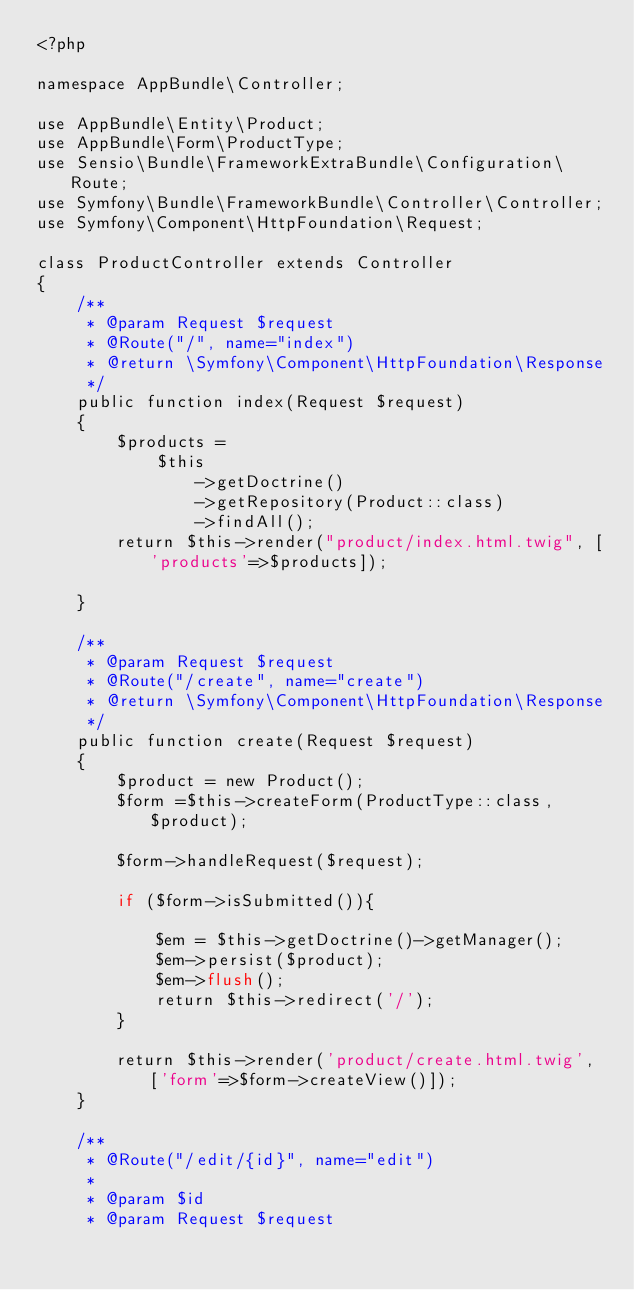<code> <loc_0><loc_0><loc_500><loc_500><_PHP_><?php

namespace AppBundle\Controller;

use AppBundle\Entity\Product;
use AppBundle\Form\ProductType;
use Sensio\Bundle\FrameworkExtraBundle\Configuration\Route;
use Symfony\Bundle\FrameworkBundle\Controller\Controller;
use Symfony\Component\HttpFoundation\Request;

class ProductController extends Controller
{
    /**
     * @param Request $request
     * @Route("/", name="index")
     * @return \Symfony\Component\HttpFoundation\Response
     */
    public function index(Request $request)
    {
        $products =
            $this
                ->getDoctrine()
                ->getRepository(Product::class)
                ->findAll();
        return $this->render("product/index.html.twig", ['products'=>$products]);
        
    }

    /**
     * @param Request $request
     * @Route("/create", name="create")
     * @return \Symfony\Component\HttpFoundation\Response
     */
    public function create(Request $request)
    {
        $product = new Product();
        $form =$this->createForm(ProductType::class, $product);

        $form->handleRequest($request);

        if ($form->isSubmitted()){

            $em = $this->getDoctrine()->getManager();
            $em->persist($product);
            $em->flush();
            return $this->redirect('/');
        }

        return $this->render('product/create.html.twig', ['form'=>$form->createView()]);
    }

    /**
     * @Route("/edit/{id}", name="edit")
     *
     * @param $id
     * @param Request $request</code> 